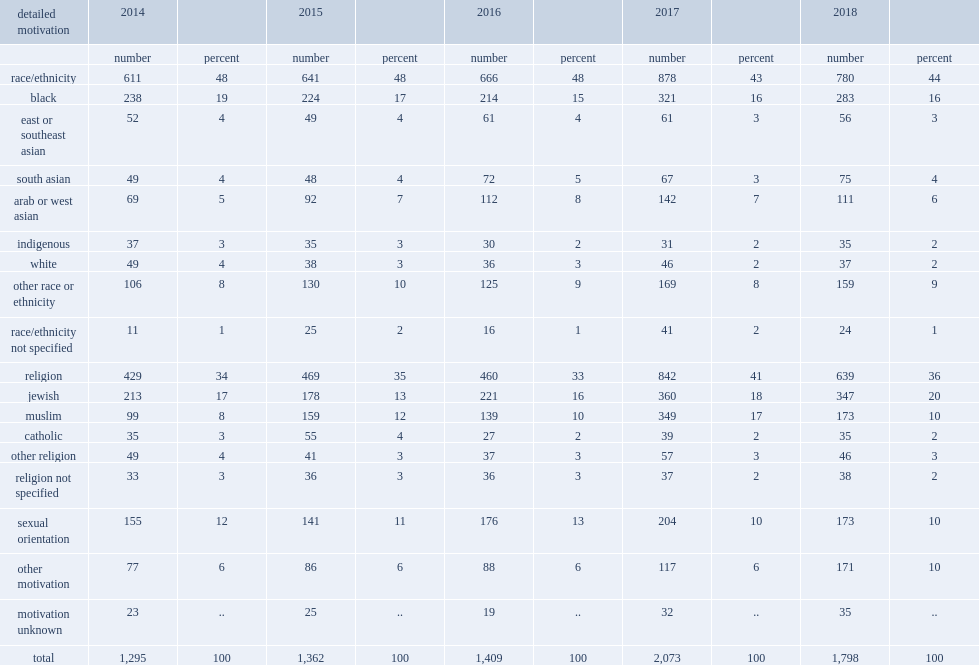What the percentage of all hate crimes did hate crimes motivated by hatred of a race or ethnicity represent in 2018? 44.0. What the percentage of all hate crimes did hate crimes motivated by hatred of targeting religion represent in 2018? 36.0. What was the percentage of hate crimes motivated by hatred of sexual orientation in 2018? 10.0. What was the percentage of hate crimes motivated by hatred of other factors such as language, disability, age, and sex in 2018? 10.0. 